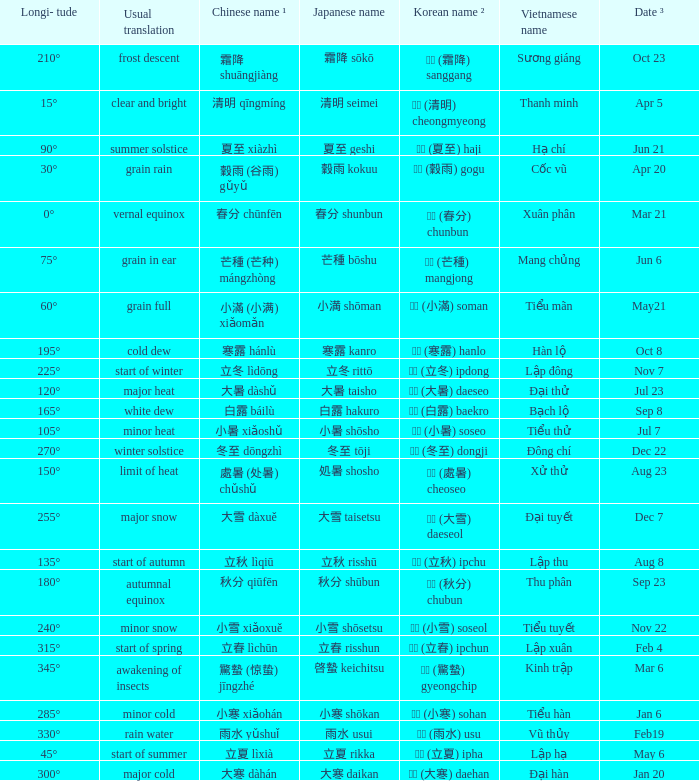Which Japanese name has a Korean name ² of 경칩 (驚蟄) gyeongchip? 啓蟄 keichitsu. 